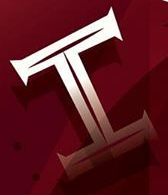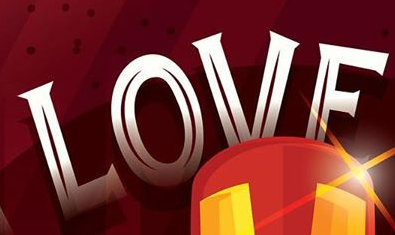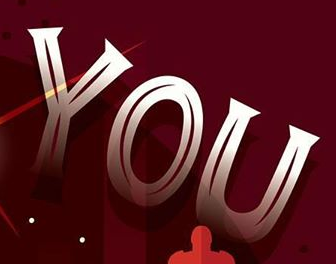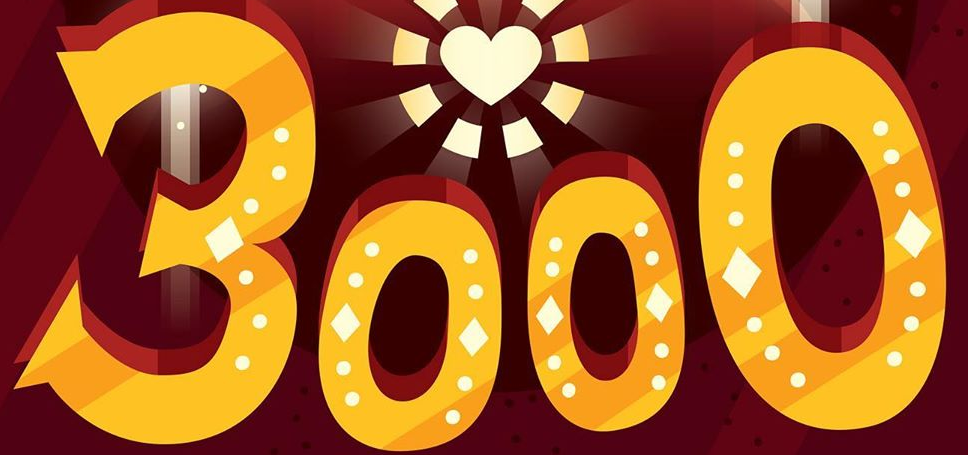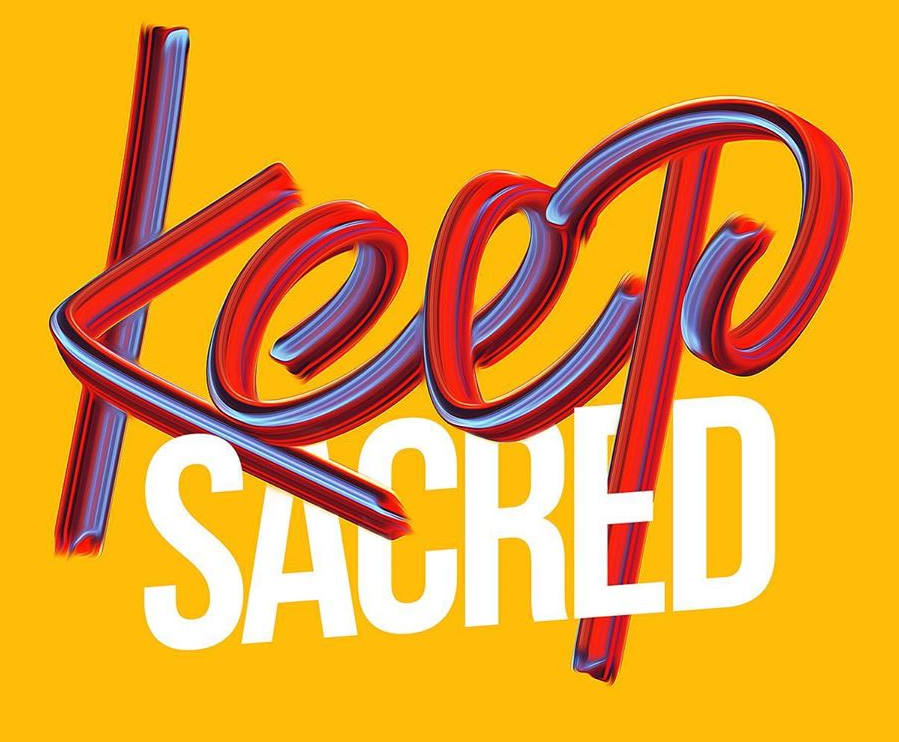Identify the words shown in these images in order, separated by a semicolon. I; LOVE; YOU; 3000; Keep 